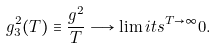<formula> <loc_0><loc_0><loc_500><loc_500>g ^ { 2 } _ { 3 } ( T ) \equiv \frac { g ^ { 2 } } { T } \longrightarrow \lim i t s ^ { T \rightarrow \infty } 0 .</formula> 